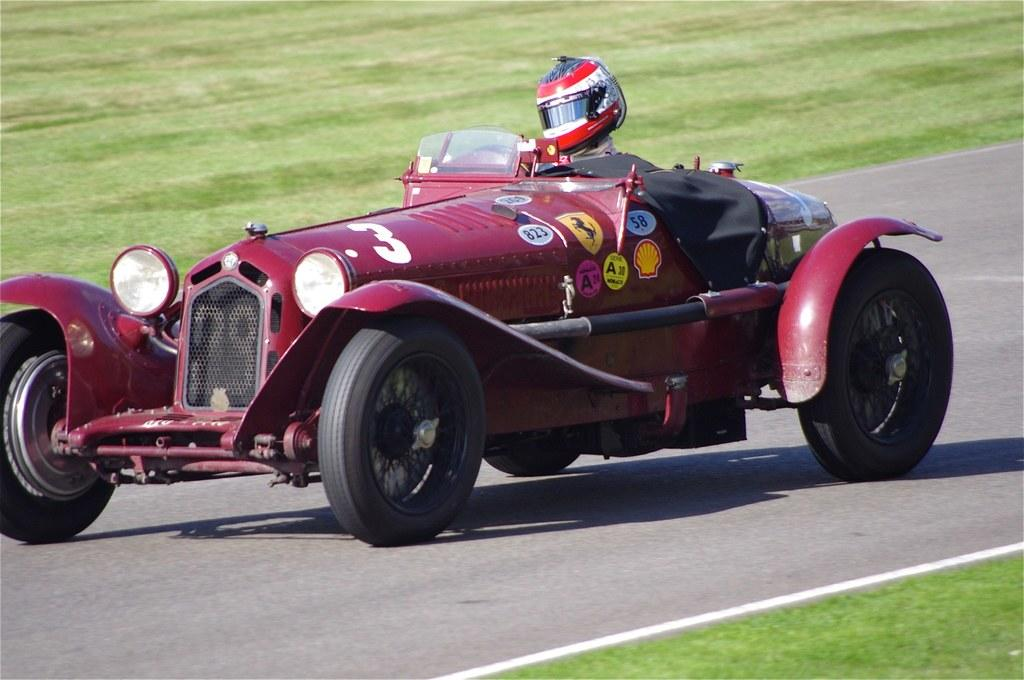What is on the road in the image? There is a vehicle on the road in the image. Who is inside the vehicle? There is a man in the vehicle. What type of landscape surrounds the road? Grassy land is present on both sides of the road. What color is the zebra grazing on the grassy land next to the road? There is no zebra present in the image; only the vehicle, the man, and the grassy land are visible. 